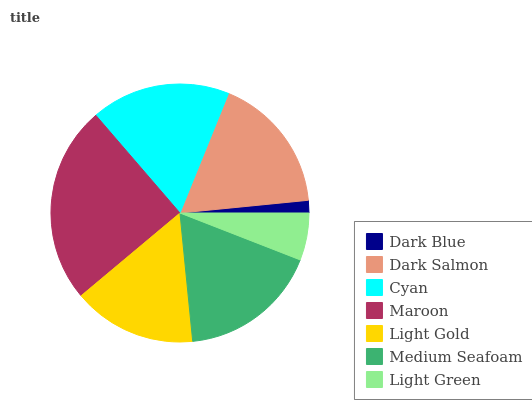Is Dark Blue the minimum?
Answer yes or no. Yes. Is Maroon the maximum?
Answer yes or no. Yes. Is Dark Salmon the minimum?
Answer yes or no. No. Is Dark Salmon the maximum?
Answer yes or no. No. Is Dark Salmon greater than Dark Blue?
Answer yes or no. Yes. Is Dark Blue less than Dark Salmon?
Answer yes or no. Yes. Is Dark Blue greater than Dark Salmon?
Answer yes or no. No. Is Dark Salmon less than Dark Blue?
Answer yes or no. No. Is Dark Salmon the high median?
Answer yes or no. Yes. Is Dark Salmon the low median?
Answer yes or no. Yes. Is Cyan the high median?
Answer yes or no. No. Is Dark Blue the low median?
Answer yes or no. No. 